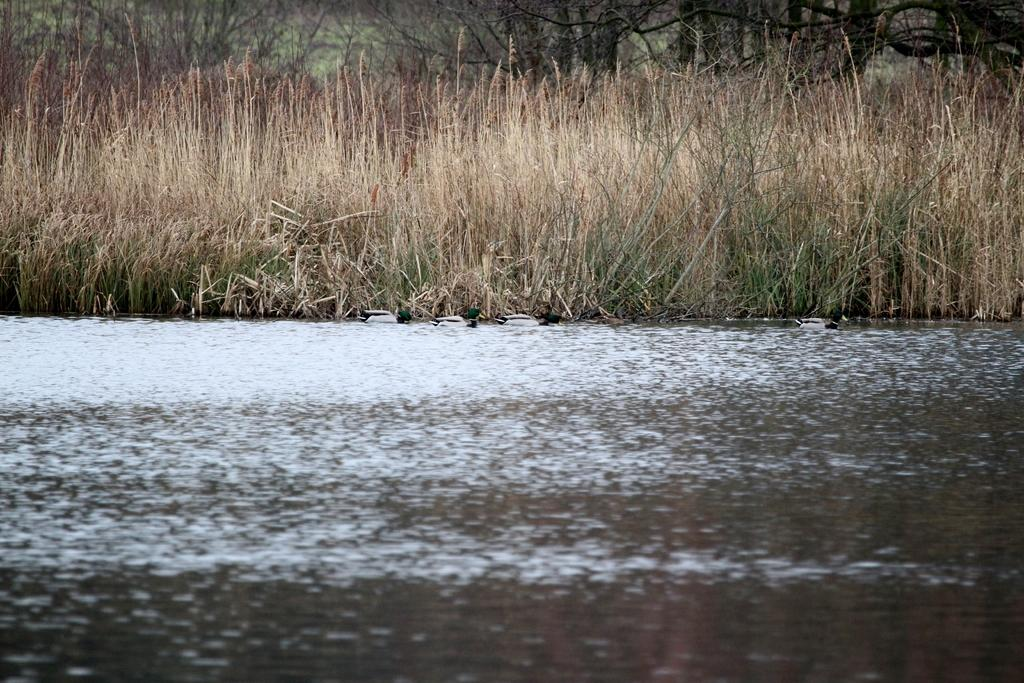What type of natural feature is present in the image? There is a river in the image. What type of vegetation can be seen in the image? There is grass and trees visible in the image. Reasoning: Let's think step by identifying the main subjects and objects in the image based on the provided facts. We then formulate questions that focus on the location and characteristics of these subjects and objects, ensuring that each question can be answered definitively with the information given. We avoid yes/no questions and ensure that the language is simple and clear. Absurd Question/Answer: What type of shoe is hanging from the tree in the image? There is no shoe present in the image; it only features a river, grass, and trees. Where can the lunchroom be found in the image? There is no lunchroom present in the image; it is an outdoor scene with a river, grass, and trees. What color is the thread used to tie the branches of the trees together in the image? There is no thread or any indication of tied branches in the image; it only features a river, grass, and trees. 